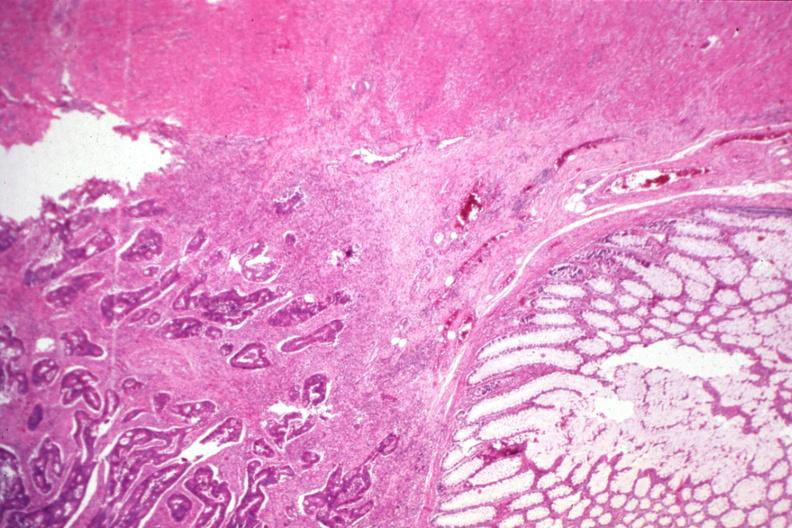what is present?
Answer the question using a single word or phrase. Colon 